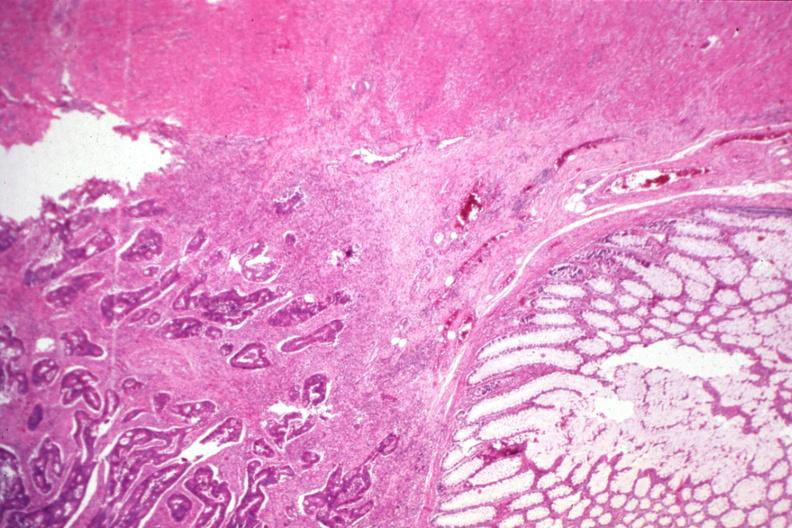what is present?
Answer the question using a single word or phrase. Colon 